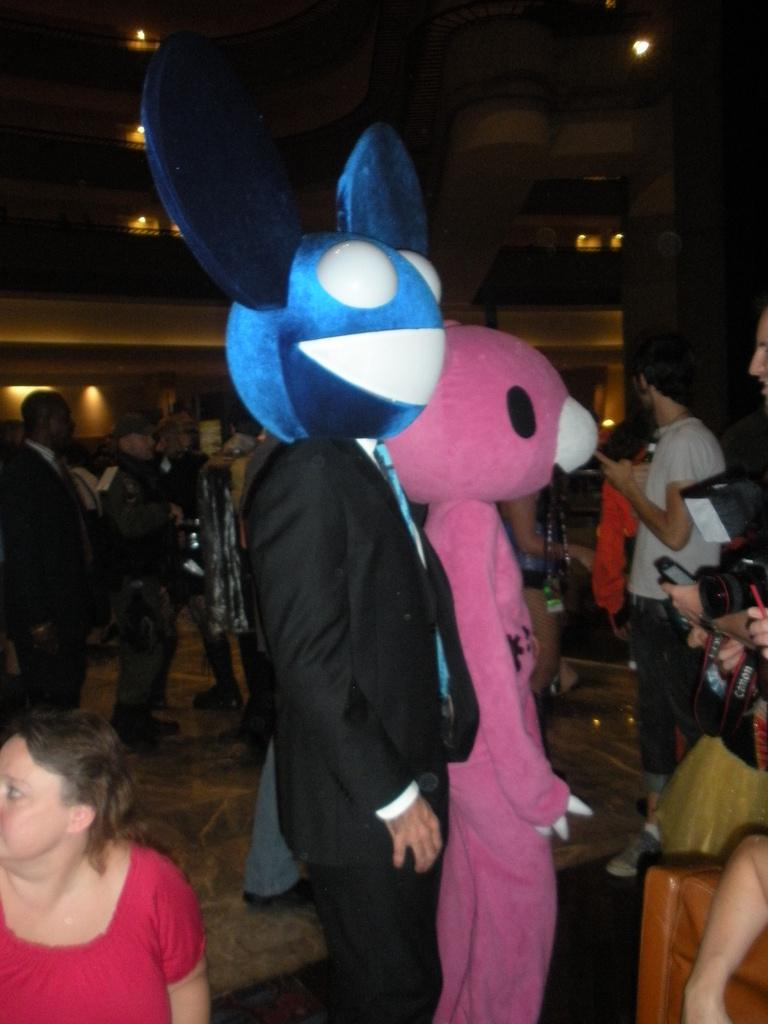What can be seen in the image besides the group of people? There are two mascots in the image. What is the setting of the image? The group of people and mascots are standing in a location where lights are visible in the background. What type of pest can be seen in the image? There is no pest present in the image; it features a group of people and two mascots. What type of drug is being administered to the mascots in the image? There is no drug or any indication of drug administration in the image. 